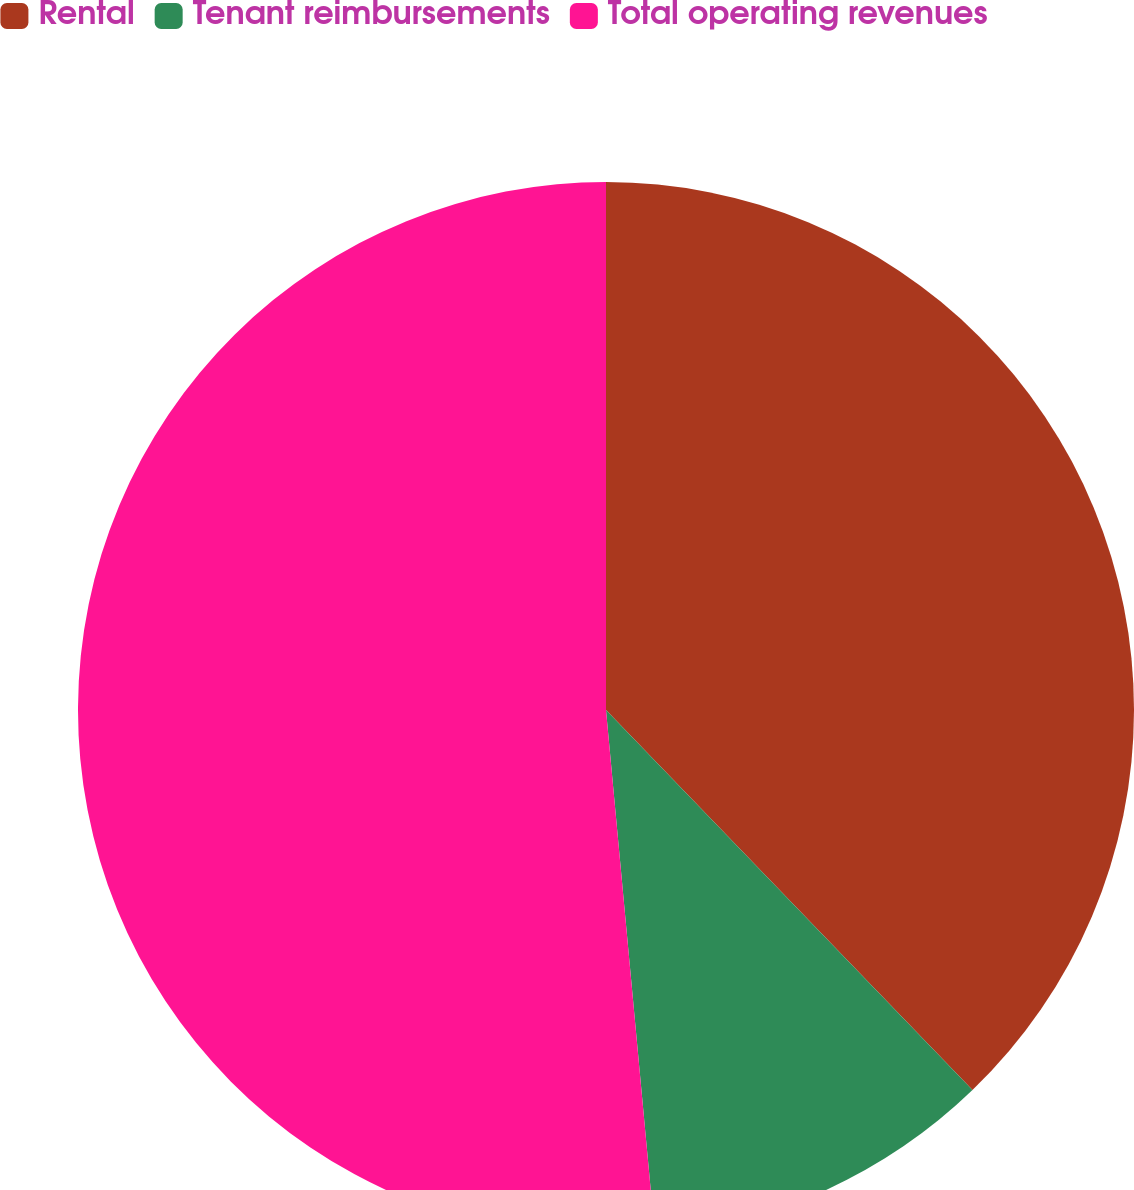Convert chart. <chart><loc_0><loc_0><loc_500><loc_500><pie_chart><fcel>Rental<fcel>Tenant reimbursements<fcel>Total operating revenues<nl><fcel>37.79%<fcel>10.73%<fcel>51.48%<nl></chart> 